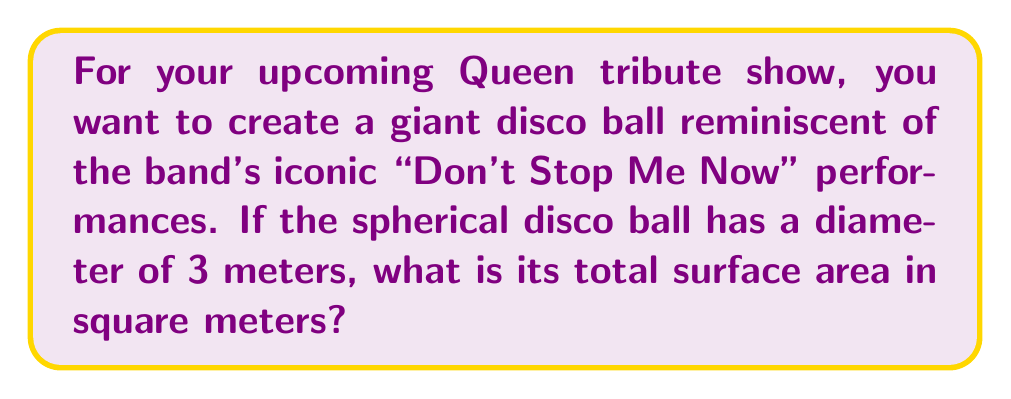Provide a solution to this math problem. Let's approach this step-by-step:

1) The formula for the surface area of a sphere is:
   $$A = 4\pi r^2$$
   where $A$ is the surface area and $r$ is the radius of the sphere.

2) We're given the diameter of 3 meters. The radius is half of the diameter:
   $$r = \frac{3}{2} = 1.5 \text{ meters}$$

3) Now, let's substitute this into our formula:
   $$A = 4\pi (1.5)^2$$

4) Simplify the squared term:
   $$A = 4\pi (2.25)$$

5) Multiply:
   $$A = 9\pi$$

6) To get the final answer in square meters, we can leave it as $9\pi$ or calculate it:
   $$A \approx 28.27 \text{ m}^2$$
Answer: $9\pi$ m² or approximately 28.27 m² 